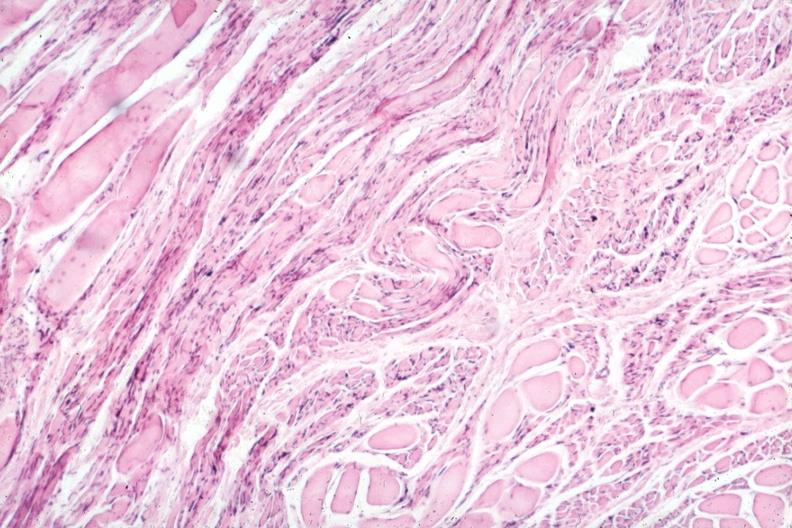does purulent sinusitis show marked neurological atrophy?
Answer the question using a single word or phrase. No 